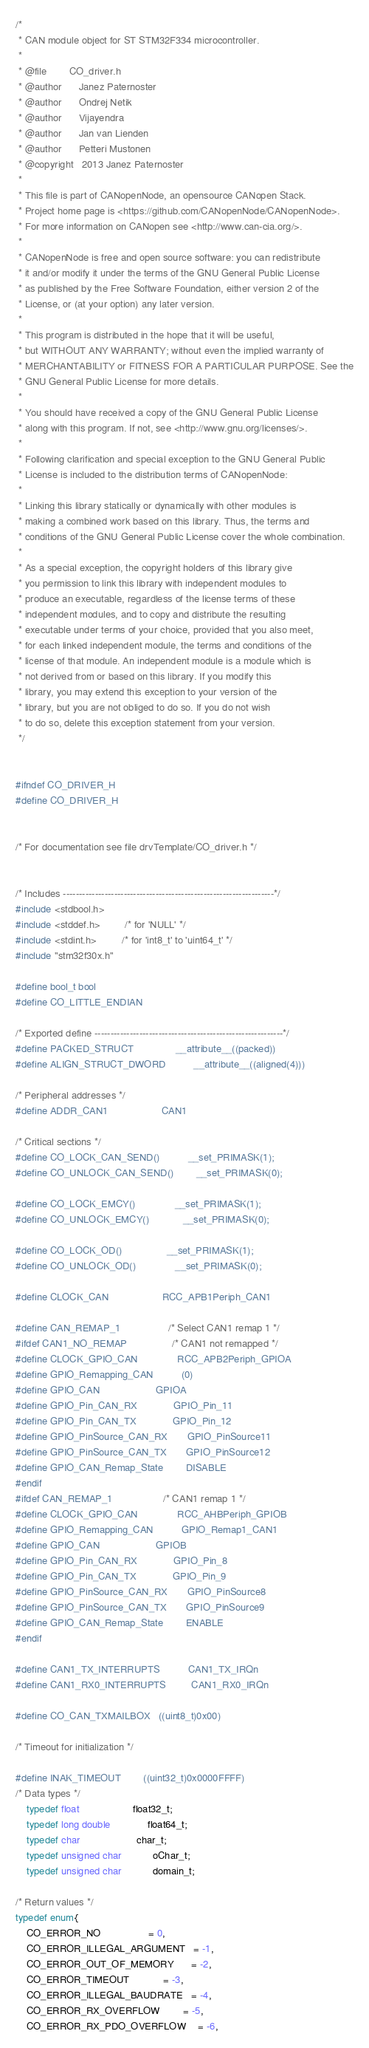Convert code to text. <code><loc_0><loc_0><loc_500><loc_500><_C_>/*
 * CAN module object for ST STM32F334 microcontroller.
 *
 * @file        CO_driver.h
 * @author      Janez Paternoster
 * @author      Ondrej Netik
 * @author      Vijayendra
 * @author      Jan van Lienden
 * @author      Petteri Mustonen
 * @copyright   2013 Janez Paternoster
 *
 * This file is part of CANopenNode, an opensource CANopen Stack.
 * Project home page is <https://github.com/CANopenNode/CANopenNode>.
 * For more information on CANopen see <http://www.can-cia.org/>.
 *
 * CANopenNode is free and open source software: you can redistribute
 * it and/or modify it under the terms of the GNU General Public License
 * as published by the Free Software Foundation, either version 2 of the
 * License, or (at your option) any later version.
 *
 * This program is distributed in the hope that it will be useful,
 * but WITHOUT ANY WARRANTY; without even the implied warranty of
 * MERCHANTABILITY or FITNESS FOR A PARTICULAR PURPOSE. See the
 * GNU General Public License for more details.
 *
 * You should have received a copy of the GNU General Public License
 * along with this program. If not, see <http://www.gnu.org/licenses/>.
 *
 * Following clarification and special exception to the GNU General Public
 * License is included to the distribution terms of CANopenNode:
 *
 * Linking this library statically or dynamically with other modules is
 * making a combined work based on this library. Thus, the terms and
 * conditions of the GNU General Public License cover the whole combination.
 *
 * As a special exception, the copyright holders of this library give
 * you permission to link this library with independent modules to
 * produce an executable, regardless of the license terms of these
 * independent modules, and to copy and distribute the resulting
 * executable under terms of your choice, provided that you also meet,
 * for each linked independent module, the terms and conditions of the
 * license of that module. An independent module is a module which is
 * not derived from or based on this library. If you modify this
 * library, you may extend this exception to your version of the
 * library, but you are not obliged to do so. If you do not wish
 * to do so, delete this exception statement from your version.
 */


#ifndef CO_DRIVER_H
#define CO_DRIVER_H


/* For documentation see file drvTemplate/CO_driver.h */


/* Includes ------------------------------------------------------------------*/
#include <stdbool.h>
#include <stddef.h>         /* for 'NULL' */
#include <stdint.h>         /* for 'int8_t' to 'uint64_t' */
#include "stm32f30x.h"

#define bool_t bool
#define CO_LITTLE_ENDIAN

/* Exported define -----------------------------------------------------------*/
#define PACKED_STRUCT               __attribute__((packed))
#define ALIGN_STRUCT_DWORD          __attribute__((aligned(4)))

/* Peripheral addresses */
#define ADDR_CAN1                   CAN1

/* Critical sections */
#define CO_LOCK_CAN_SEND()          __set_PRIMASK(1);
#define CO_UNLOCK_CAN_SEND()        __set_PRIMASK(0);

#define CO_LOCK_EMCY()              __set_PRIMASK(1);
#define CO_UNLOCK_EMCY()            __set_PRIMASK(0);

#define CO_LOCK_OD()                __set_PRIMASK(1);
#define CO_UNLOCK_OD()              __set_PRIMASK(0);

#define CLOCK_CAN                   RCC_APB1Periph_CAN1

#define CAN_REMAP_1                 /* Select CAN1 remap 1 */
#ifdef CAN1_NO_REMAP                /* CAN1 not remapped */
#define CLOCK_GPIO_CAN              RCC_APB2Periph_GPIOA
#define GPIO_Remapping_CAN          (0)
#define GPIO_CAN                    GPIOA
#define GPIO_Pin_CAN_RX             GPIO_Pin_11
#define GPIO_Pin_CAN_TX             GPIO_Pin_12
#define GPIO_PinSource_CAN_RX       GPIO_PinSource11
#define GPIO_PinSource_CAN_TX       GPIO_PinSource12
#define GPIO_CAN_Remap_State        DISABLE
#endif
#ifdef CAN_REMAP_1                  /* CAN1 remap 1 */
#define CLOCK_GPIO_CAN              RCC_AHBPeriph_GPIOB
#define GPIO_Remapping_CAN          GPIO_Remap1_CAN1
#define GPIO_CAN                    GPIOB
#define GPIO_Pin_CAN_RX             GPIO_Pin_8
#define GPIO_Pin_CAN_TX             GPIO_Pin_9
#define GPIO_PinSource_CAN_RX       GPIO_PinSource8
#define GPIO_PinSource_CAN_TX       GPIO_PinSource9
#define GPIO_CAN_Remap_State        ENABLE
#endif

#define CAN1_TX_INTERRUPTS          CAN1_TX_IRQn
#define CAN1_RX0_INTERRUPTS         CAN1_RX0_IRQn

#define CO_CAN_TXMAILBOX   ((uint8_t)0x00)

/* Timeout for initialization */

#define INAK_TIMEOUT        ((uint32_t)0x0000FFFF)
/* Data types */
    typedef float                   float32_t;
    typedef long double             float64_t;
    typedef char                    char_t;
    typedef unsigned char           oChar_t;
    typedef unsigned char           domain_t;

/* Return values */
typedef enum{
    CO_ERROR_NO                 = 0,
    CO_ERROR_ILLEGAL_ARGUMENT   = -1,
    CO_ERROR_OUT_OF_MEMORY      = -2,
    CO_ERROR_TIMEOUT            = -3,
    CO_ERROR_ILLEGAL_BAUDRATE   = -4,
    CO_ERROR_RX_OVERFLOW        = -5,
    CO_ERROR_RX_PDO_OVERFLOW    = -6,</code> 